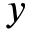Convert formula to latex. <formula><loc_0><loc_0><loc_500><loc_500>y</formula> 